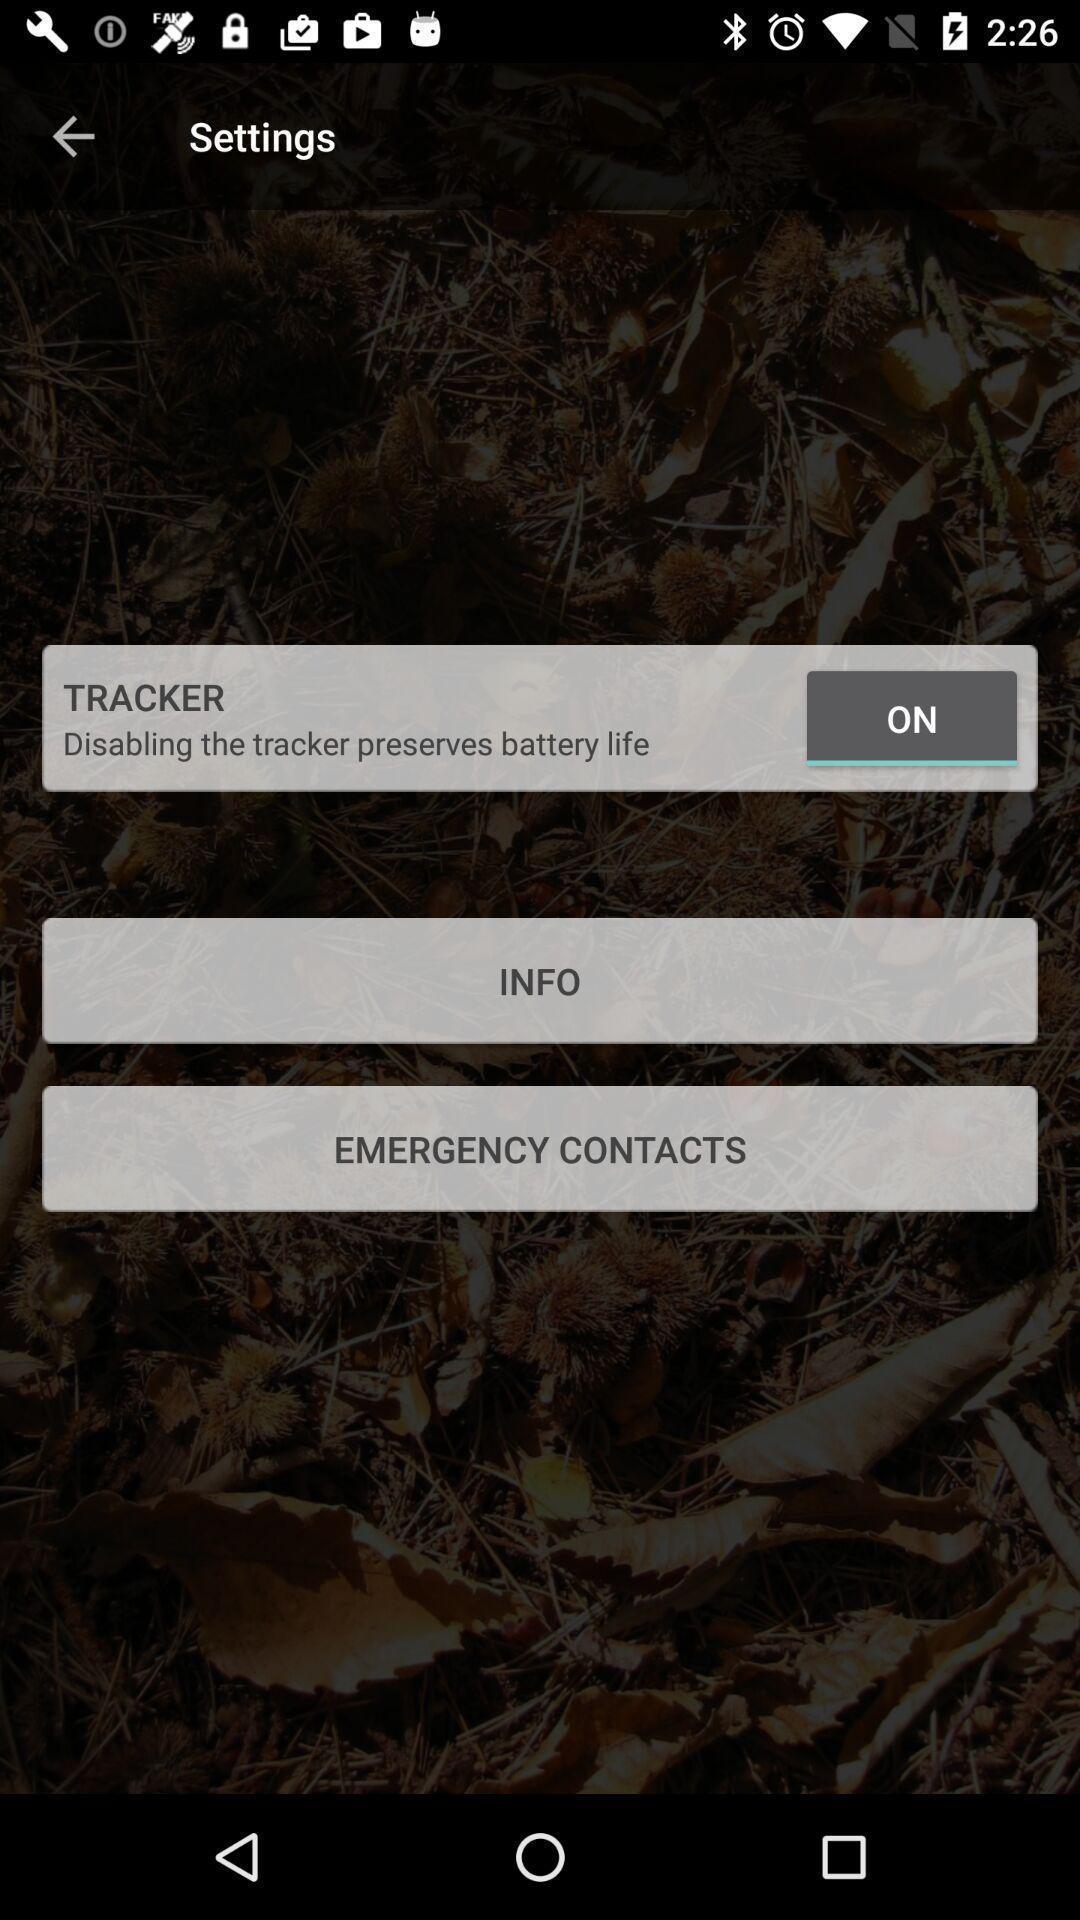Provide a detailed account of this screenshot. Settings page with various options. 